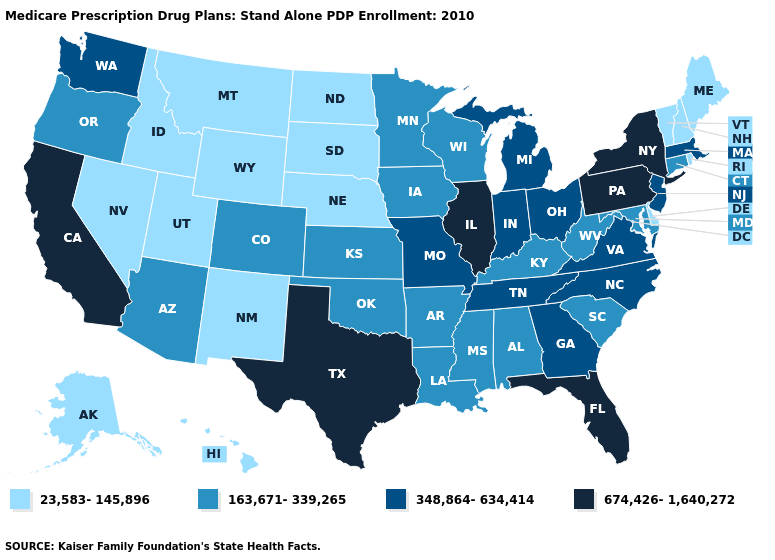Name the states that have a value in the range 674,426-1,640,272?
Quick response, please. California, Florida, Illinois, New York, Pennsylvania, Texas. What is the highest value in states that border South Carolina?
Write a very short answer. 348,864-634,414. Name the states that have a value in the range 674,426-1,640,272?
Quick response, please. California, Florida, Illinois, New York, Pennsylvania, Texas. Is the legend a continuous bar?
Write a very short answer. No. What is the lowest value in states that border Alabama?
Keep it brief. 163,671-339,265. Name the states that have a value in the range 348,864-634,414?
Short answer required. Georgia, Indiana, Massachusetts, Michigan, Missouri, North Carolina, New Jersey, Ohio, Tennessee, Virginia, Washington. What is the lowest value in the West?
Quick response, please. 23,583-145,896. Among the states that border Pennsylvania , which have the highest value?
Quick response, please. New York. Name the states that have a value in the range 348,864-634,414?
Write a very short answer. Georgia, Indiana, Massachusetts, Michigan, Missouri, North Carolina, New Jersey, Ohio, Tennessee, Virginia, Washington. What is the lowest value in states that border Missouri?
Concise answer only. 23,583-145,896. What is the value of Rhode Island?
Short answer required. 23,583-145,896. How many symbols are there in the legend?
Concise answer only. 4. What is the value of New Mexico?
Give a very brief answer. 23,583-145,896. Among the states that border Texas , which have the highest value?
Answer briefly. Arkansas, Louisiana, Oklahoma. Does New Mexico have the lowest value in the West?
Short answer required. Yes. 